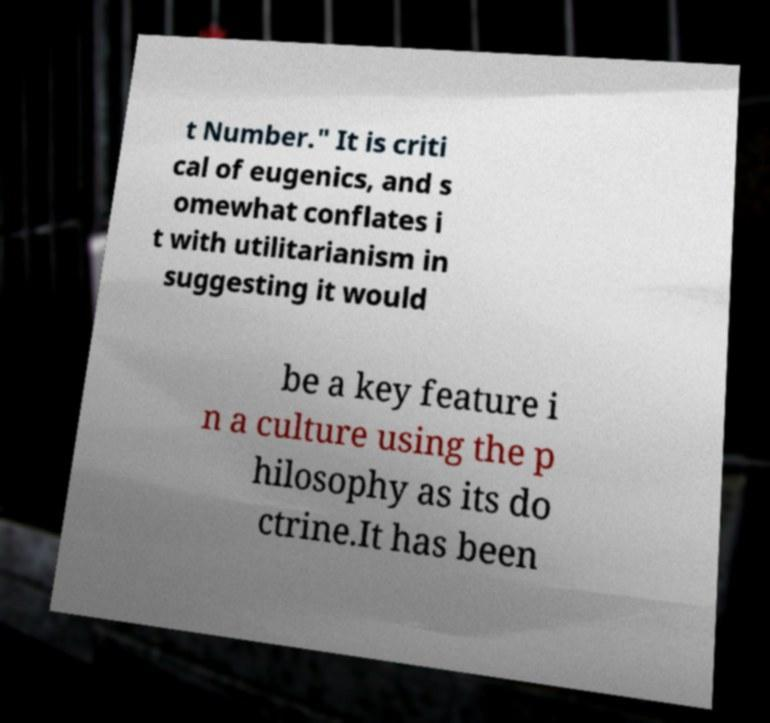Could you assist in decoding the text presented in this image and type it out clearly? t Number." It is criti cal of eugenics, and s omewhat conflates i t with utilitarianism in suggesting it would be a key feature i n a culture using the p hilosophy as its do ctrine.It has been 